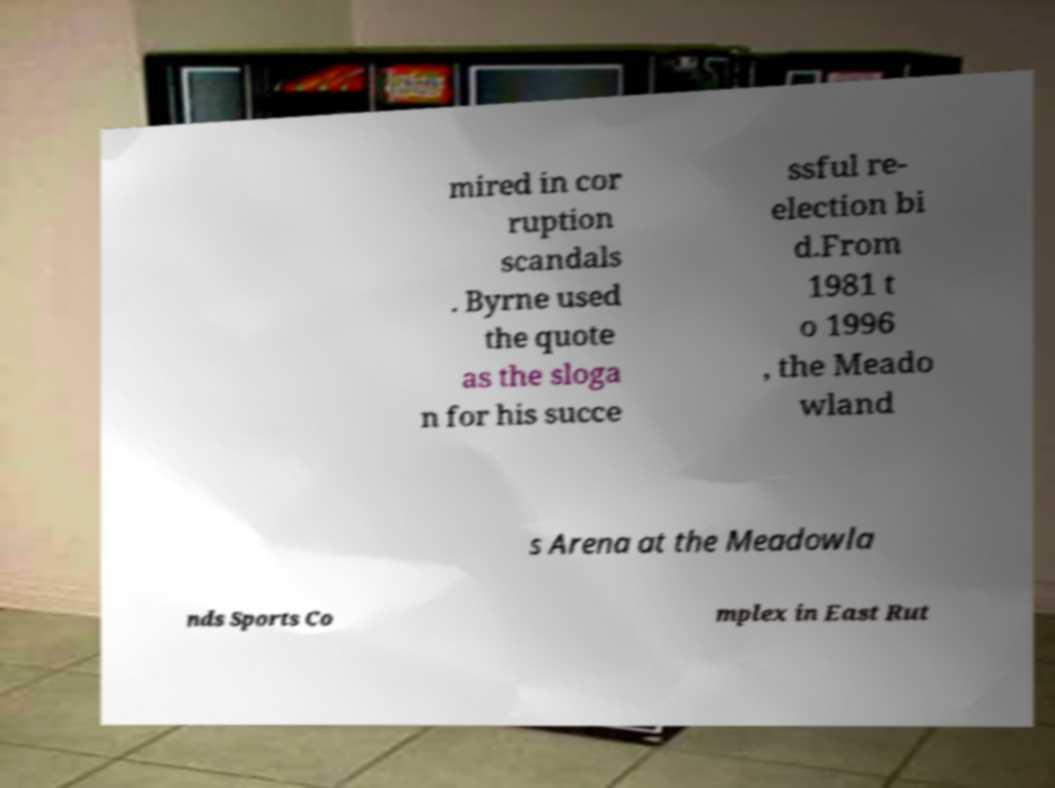Please read and relay the text visible in this image. What does it say? mired in cor ruption scandals . Byrne used the quote as the sloga n for his succe ssful re- election bi d.From 1981 t o 1996 , the Meado wland s Arena at the Meadowla nds Sports Co mplex in East Rut 